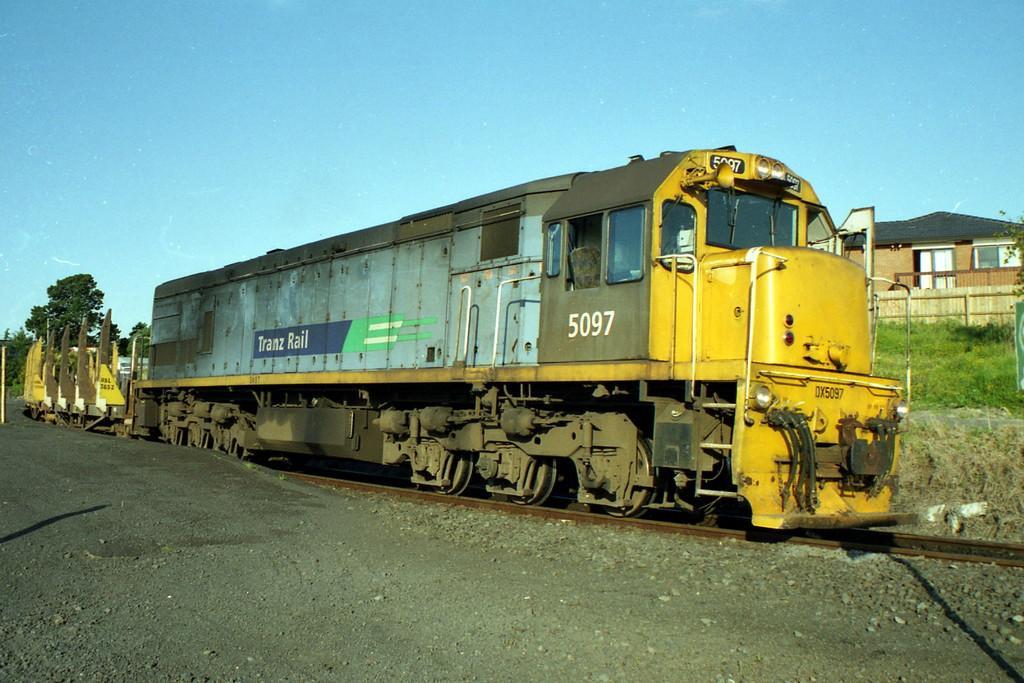Describe this image in one or two sentences. In this image we can see a train on the track. On the train we can see some text. Beside the track we can see the stones. On the right side, we can see the grass and a house. On the left side, we can see the trees. At the top we can see the sky. 